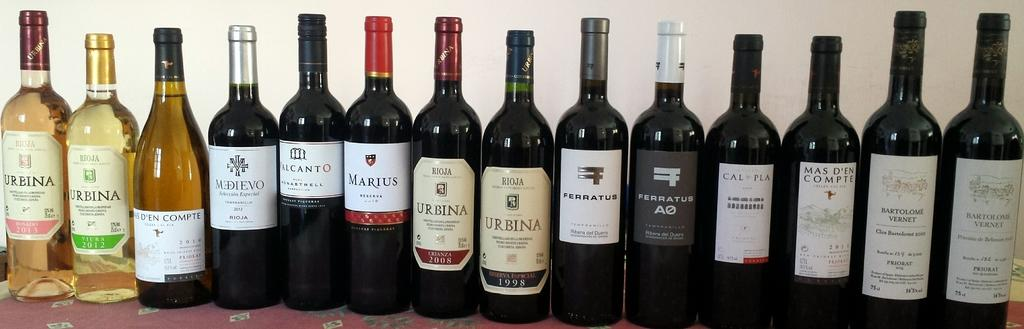<image>
Describe the image concisely. A row of wine bottles are lined in a row sitting on a table and one of the brands shown is called URBINA. 